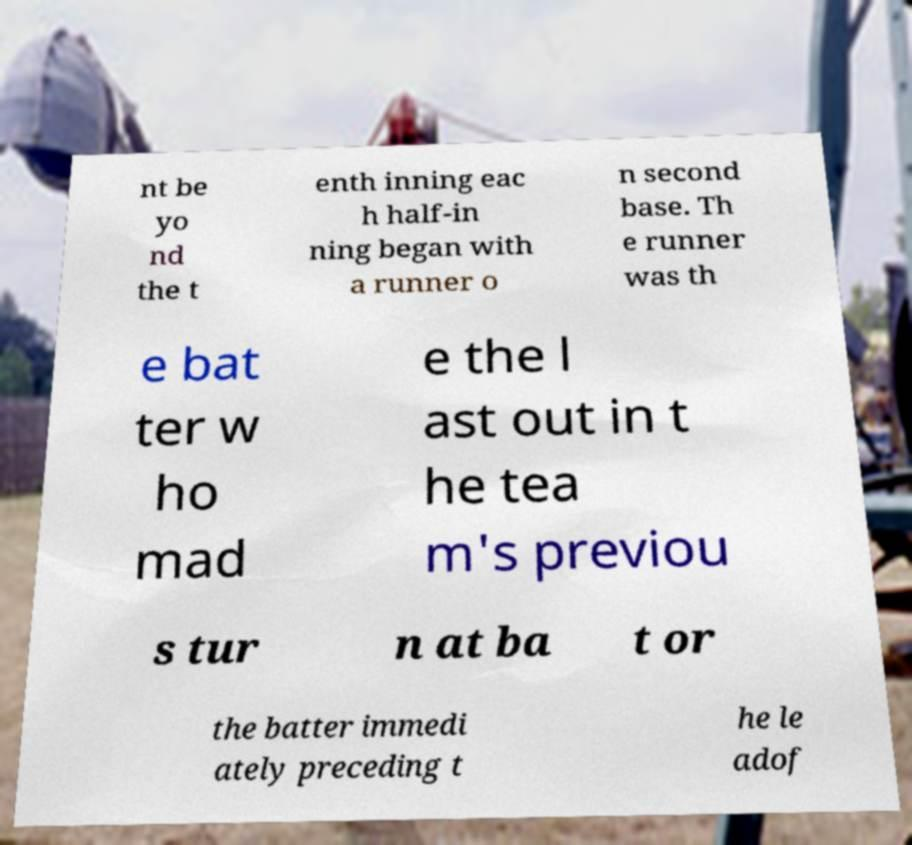For documentation purposes, I need the text within this image transcribed. Could you provide that? nt be yo nd the t enth inning eac h half-in ning began with a runner o n second base. Th e runner was th e bat ter w ho mad e the l ast out in t he tea m's previou s tur n at ba t or the batter immedi ately preceding t he le adof 